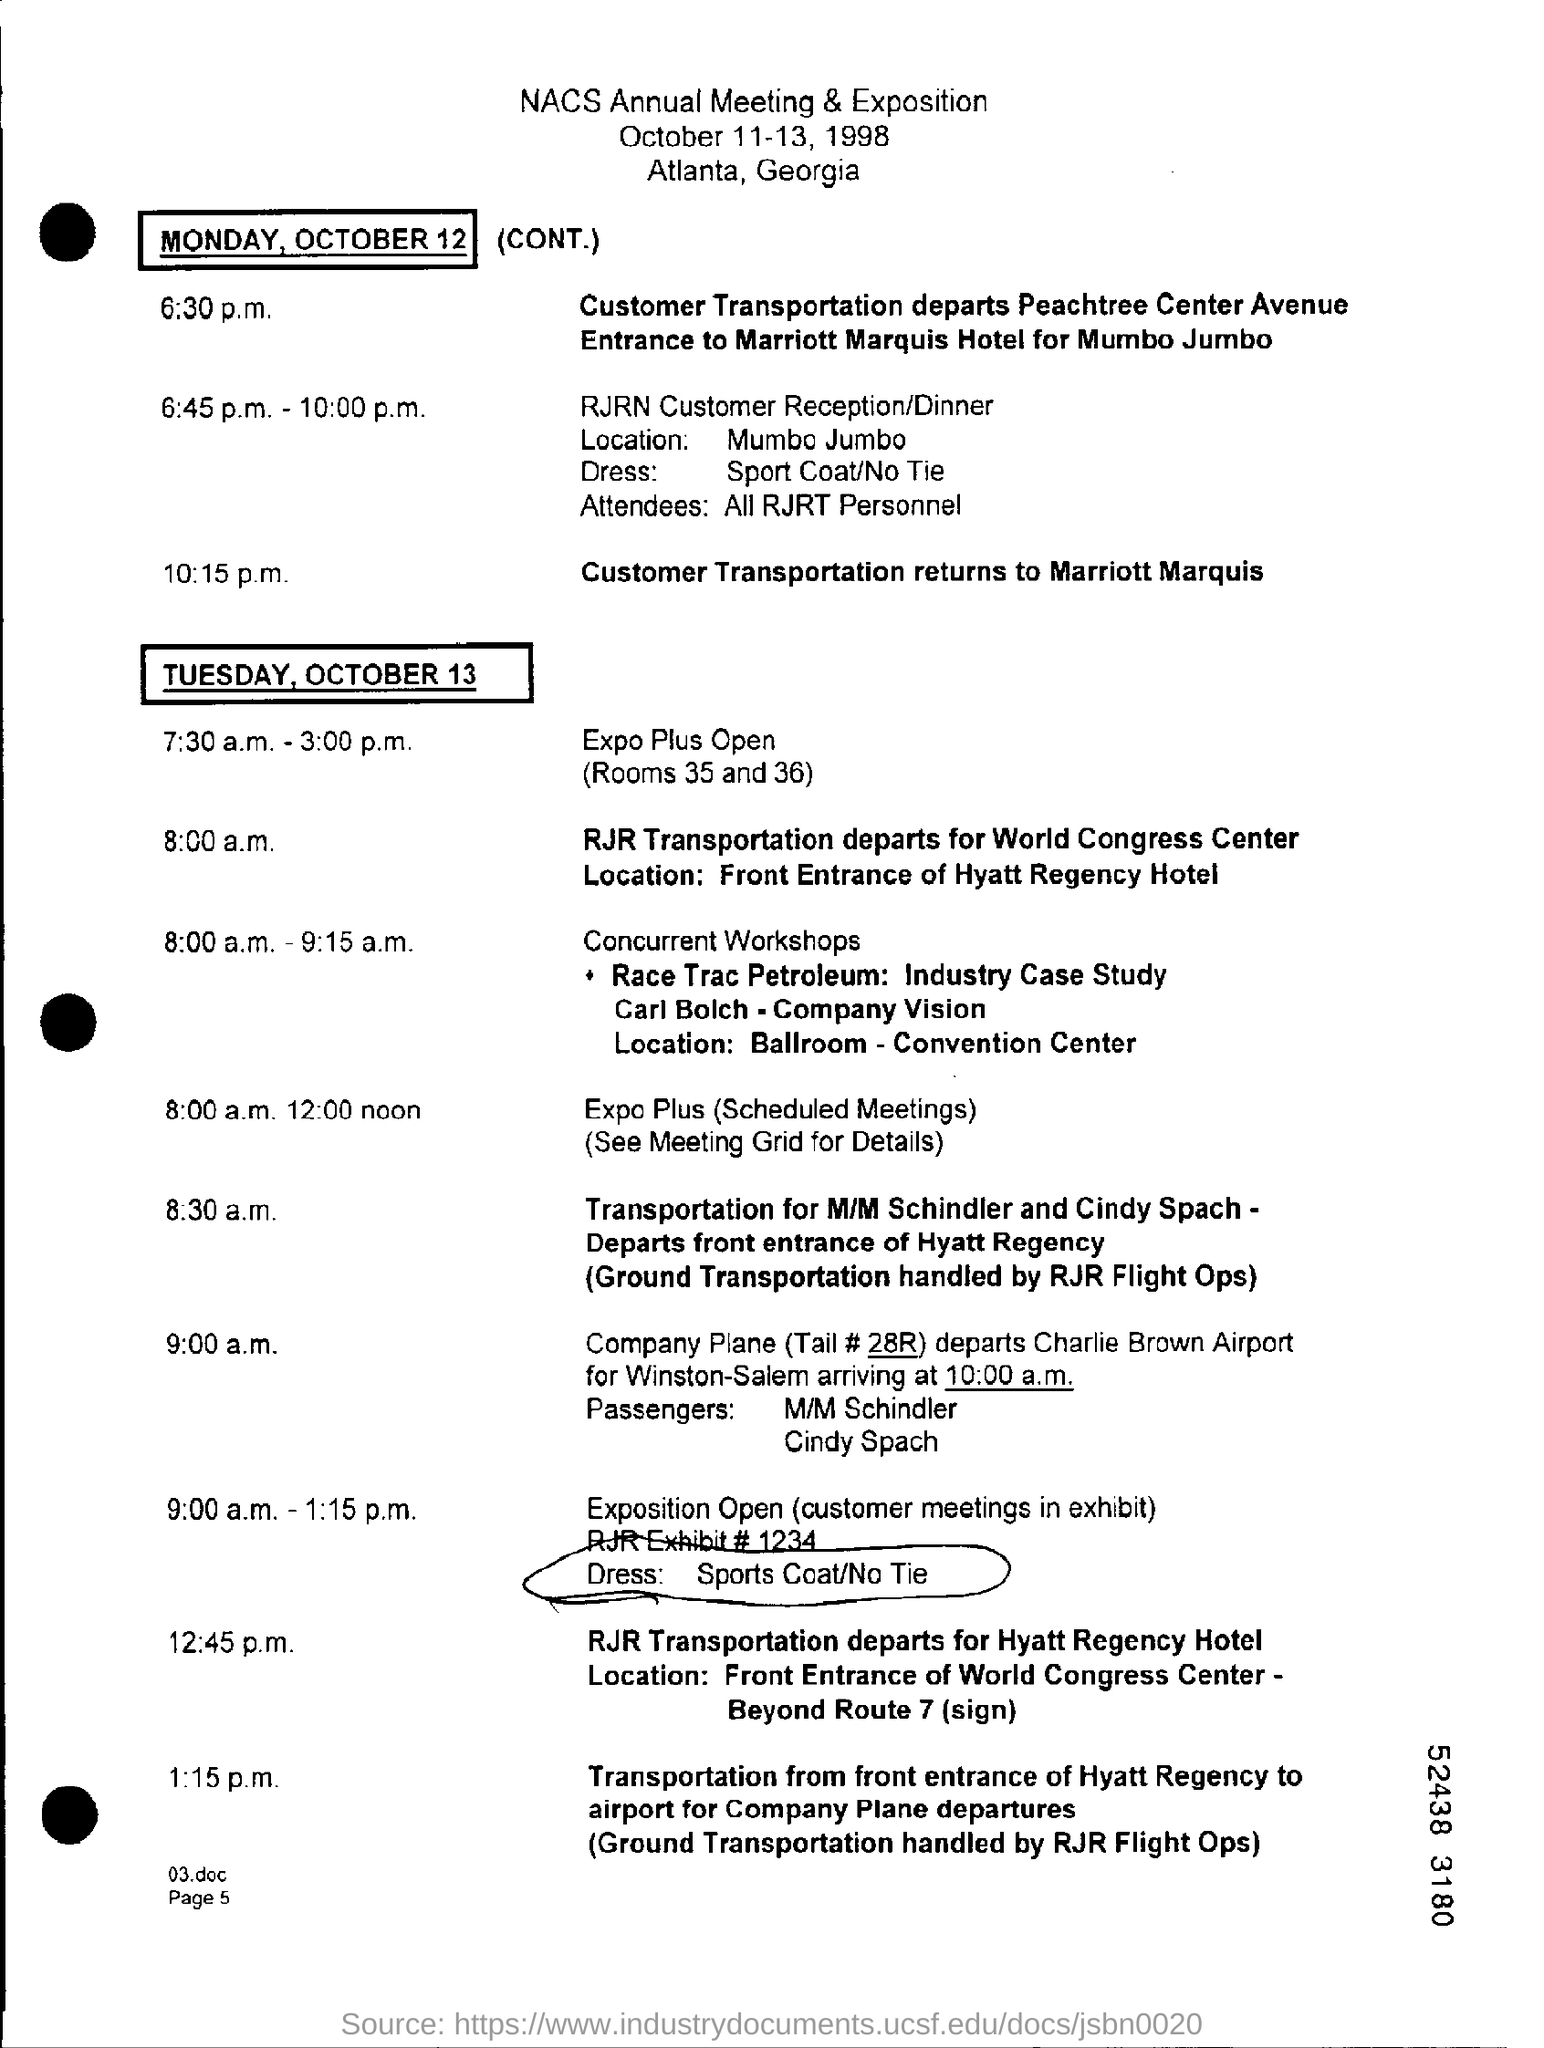When is the NACS Annual Meeting & Exposition?
Give a very brief answer. October 11-13, 1998. Where is the RJRN Customer Reception/Dinner?
Make the answer very short. Mumbo Jumbo. What is the Dress?
Offer a terse response. Sport Coat/No Tie. Who are the attendees?
Offer a terse response. All RJRT Personnel. Where does the customer Transportation return to?
Your response must be concise. Marriott Marquis. Where does RJR Transpotation depart for on Tuesday, October 13 at 8:00 a.m.?
Your response must be concise. World Congress Center. When was the NACS Annual Meeting & Exposition scheduled?
Make the answer very short. October 11-13, 1998. 